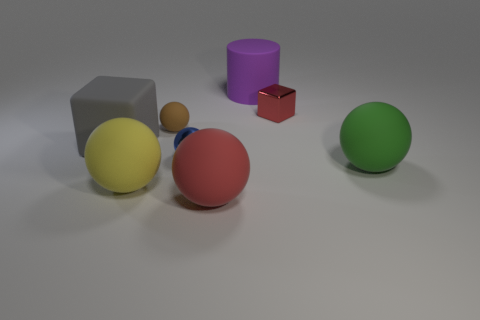There is a large cube that is made of the same material as the large green object; what is its color?
Offer a very short reply. Gray. There is a green object; what shape is it?
Provide a short and direct response. Sphere. What material is the ball right of the red ball?
Provide a short and direct response. Rubber. Is there a small metal sphere that has the same color as the small block?
Provide a short and direct response. No. What is the shape of the purple matte object that is the same size as the red rubber ball?
Offer a terse response. Cylinder. There is a big thing that is behind the gray object; what color is it?
Provide a succinct answer. Purple. There is a small sphere that is on the left side of the blue object; are there any big matte objects that are on the left side of it?
Your answer should be compact. Yes. What number of things are either objects left of the big purple matte object or blue balls?
Make the answer very short. 5. Is there anything else that is the same size as the yellow object?
Provide a succinct answer. Yes. There is a cube left of the small metallic thing that is left of the large red rubber sphere; what is it made of?
Make the answer very short. Rubber. 